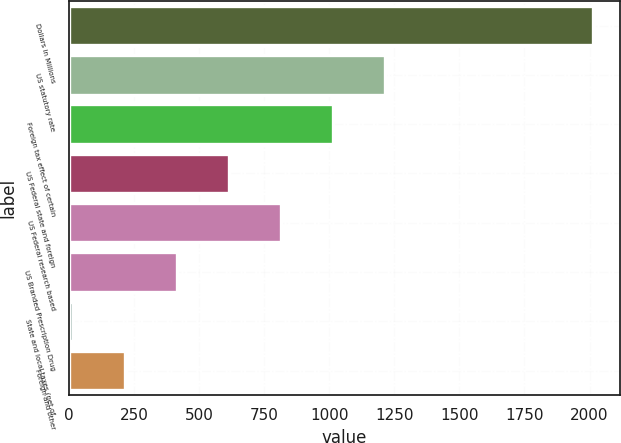Convert chart. <chart><loc_0><loc_0><loc_500><loc_500><bar_chart><fcel>Dollars in Millions<fcel>US statutory rate<fcel>Foreign tax effect of certain<fcel>US Federal state and foreign<fcel>US Federal research based<fcel>US Branded Prescription Drug<fcel>State and local taxes (net of<fcel>Foreign and other<nl><fcel>2015<fcel>1215.4<fcel>1015.5<fcel>615.7<fcel>815.6<fcel>415.8<fcel>16<fcel>215.9<nl></chart> 